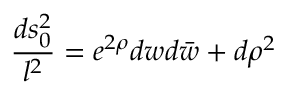Convert formula to latex. <formula><loc_0><loc_0><loc_500><loc_500>{ \frac { d s _ { 0 } ^ { 2 } } { l ^ { 2 } } } = e ^ { 2 \rho } d w d \bar { w } + d \rho ^ { 2 }</formula> 